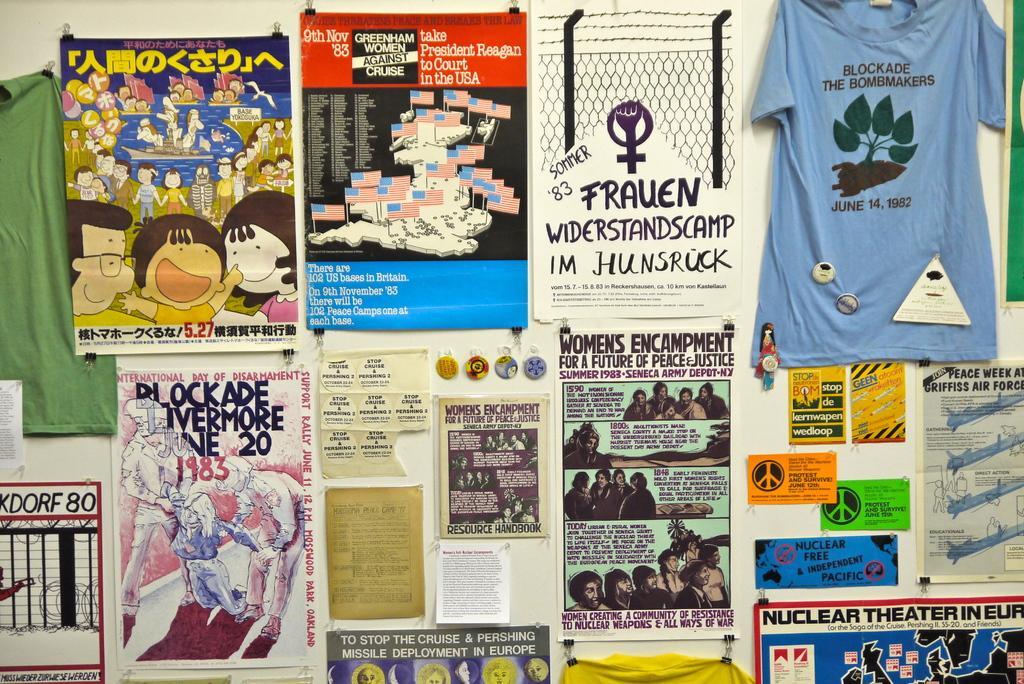What is present on the wall in the image? There are books, hoardings, charts, t-shirts, and cards on the wall in the image. Can you describe the types of items on the wall? The wall features books, hoardings, charts, t-shirts, and cards. What might be the purpose of having these items on the wall? The items on the wall could serve as decoration, information, or organization. What type of fog can be seen in the image? There is no fog present in the image; it features a wall with various items on it. 